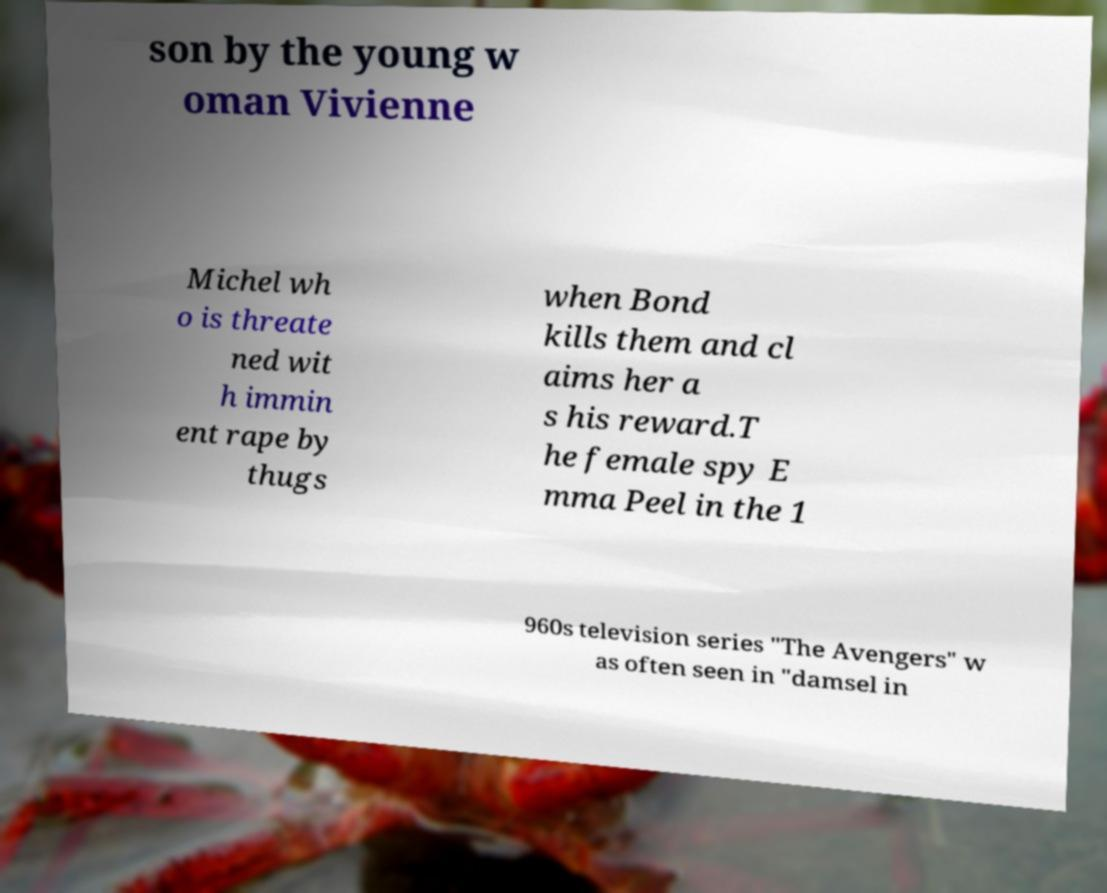Please identify and transcribe the text found in this image. son by the young w oman Vivienne Michel wh o is threate ned wit h immin ent rape by thugs when Bond kills them and cl aims her a s his reward.T he female spy E mma Peel in the 1 960s television series "The Avengers" w as often seen in "damsel in 